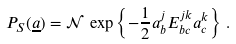<formula> <loc_0><loc_0><loc_500><loc_500>P _ { S } ( \underline { a } ) = \mathcal { N } \, \exp \left \{ - \frac { 1 } { 2 } a _ { b } ^ { j } E _ { b c } ^ { j k } a _ { c } ^ { k } \right \} \, .</formula> 